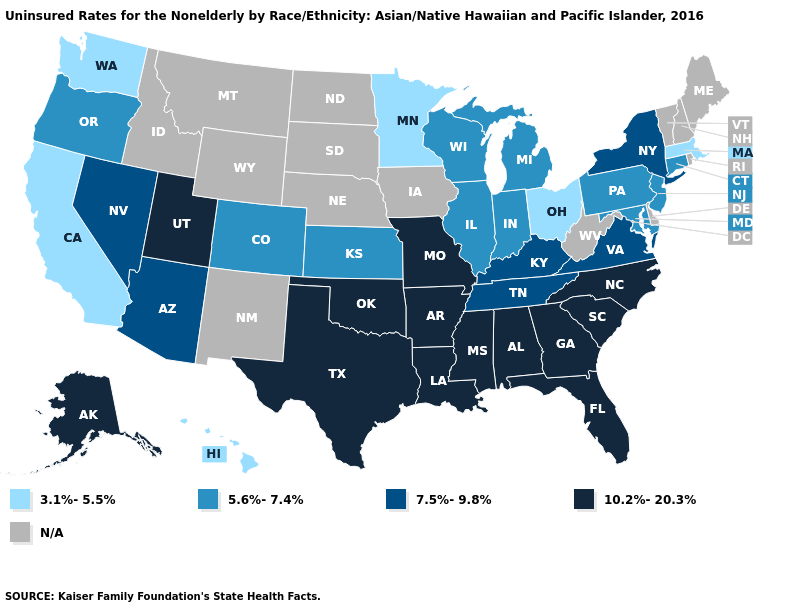Name the states that have a value in the range 3.1%-5.5%?
Write a very short answer. California, Hawaii, Massachusetts, Minnesota, Ohio, Washington. What is the highest value in states that border Rhode Island?
Give a very brief answer. 5.6%-7.4%. Name the states that have a value in the range N/A?
Write a very short answer. Delaware, Idaho, Iowa, Maine, Montana, Nebraska, New Hampshire, New Mexico, North Dakota, Rhode Island, South Dakota, Vermont, West Virginia, Wyoming. What is the highest value in states that border Alabama?
Give a very brief answer. 10.2%-20.3%. Name the states that have a value in the range 3.1%-5.5%?
Concise answer only. California, Hawaii, Massachusetts, Minnesota, Ohio, Washington. What is the value of Massachusetts?
Be succinct. 3.1%-5.5%. What is the lowest value in the USA?
Write a very short answer. 3.1%-5.5%. Does Maryland have the highest value in the South?
Be succinct. No. Is the legend a continuous bar?
Be succinct. No. Name the states that have a value in the range 3.1%-5.5%?
Concise answer only. California, Hawaii, Massachusetts, Minnesota, Ohio, Washington. Is the legend a continuous bar?
Concise answer only. No. Name the states that have a value in the range 10.2%-20.3%?
Write a very short answer. Alabama, Alaska, Arkansas, Florida, Georgia, Louisiana, Mississippi, Missouri, North Carolina, Oklahoma, South Carolina, Texas, Utah. What is the value of Connecticut?
Be succinct. 5.6%-7.4%. Does New Jersey have the lowest value in the Northeast?
Short answer required. No. Which states have the lowest value in the USA?
Be succinct. California, Hawaii, Massachusetts, Minnesota, Ohio, Washington. 